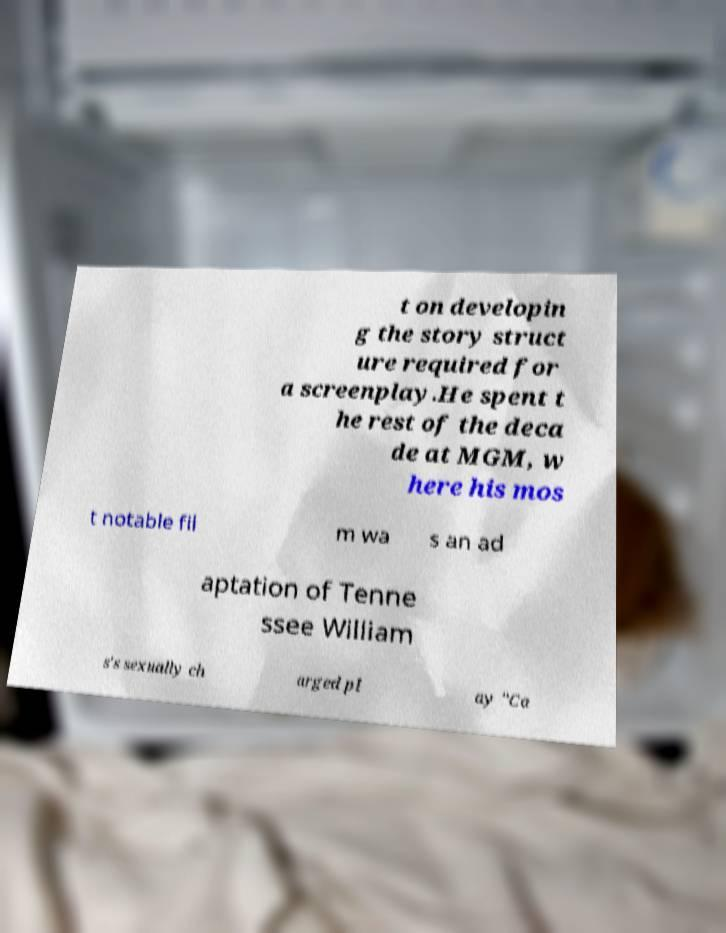Please identify and transcribe the text found in this image. t on developin g the story struct ure required for a screenplay.He spent t he rest of the deca de at MGM, w here his mos t notable fil m wa s an ad aptation of Tenne ssee William s's sexually ch arged pl ay "Ca 